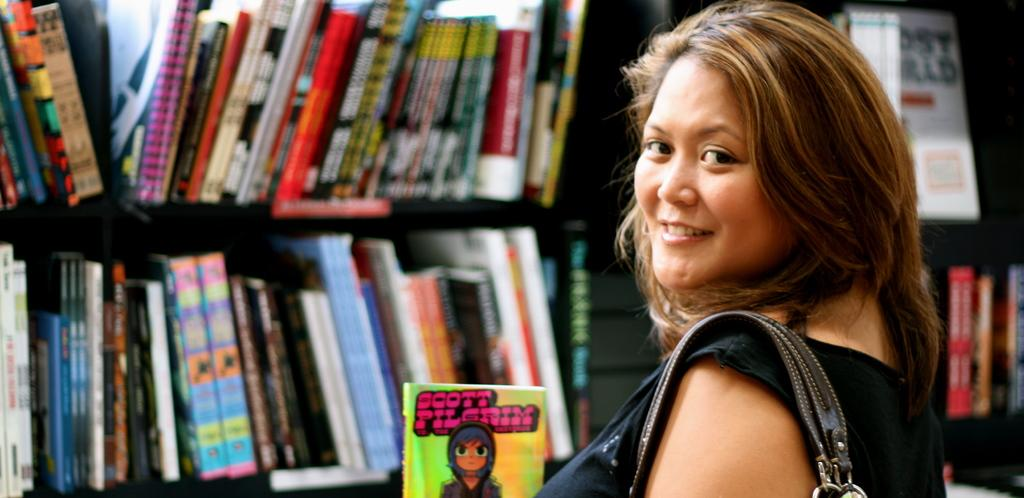<image>
Offer a succinct explanation of the picture presented. a lady next to a book that has the name Scott Pilgrim on it 